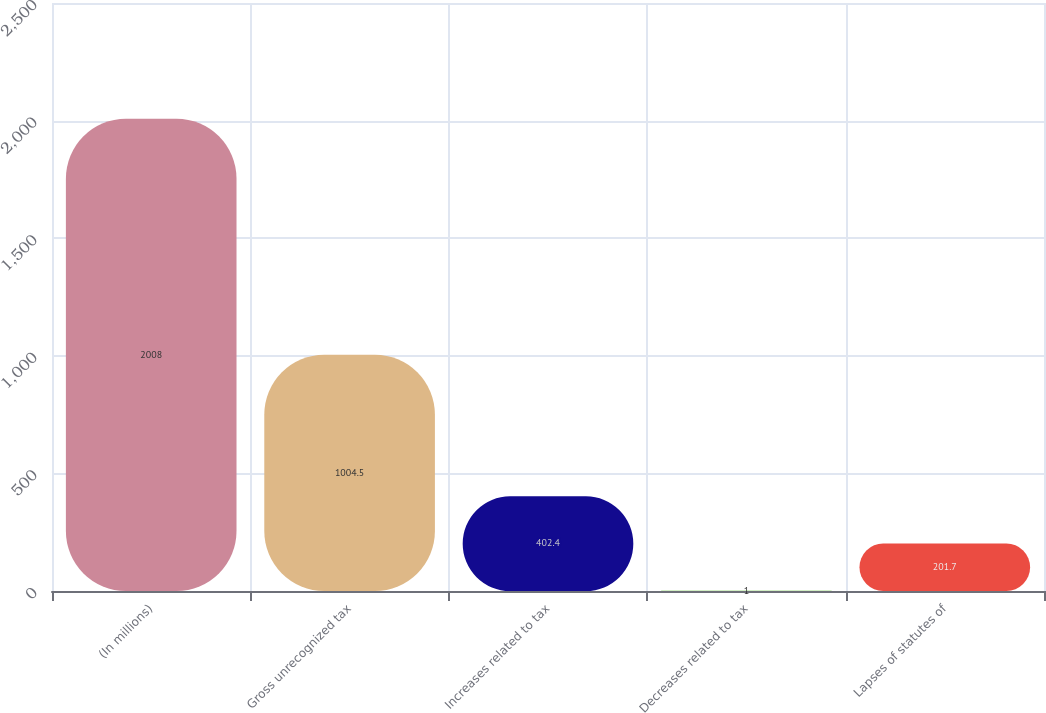<chart> <loc_0><loc_0><loc_500><loc_500><bar_chart><fcel>(In millions)<fcel>Gross unrecognized tax<fcel>Increases related to tax<fcel>Decreases related to tax<fcel>Lapses of statutes of<nl><fcel>2008<fcel>1004.5<fcel>402.4<fcel>1<fcel>201.7<nl></chart> 